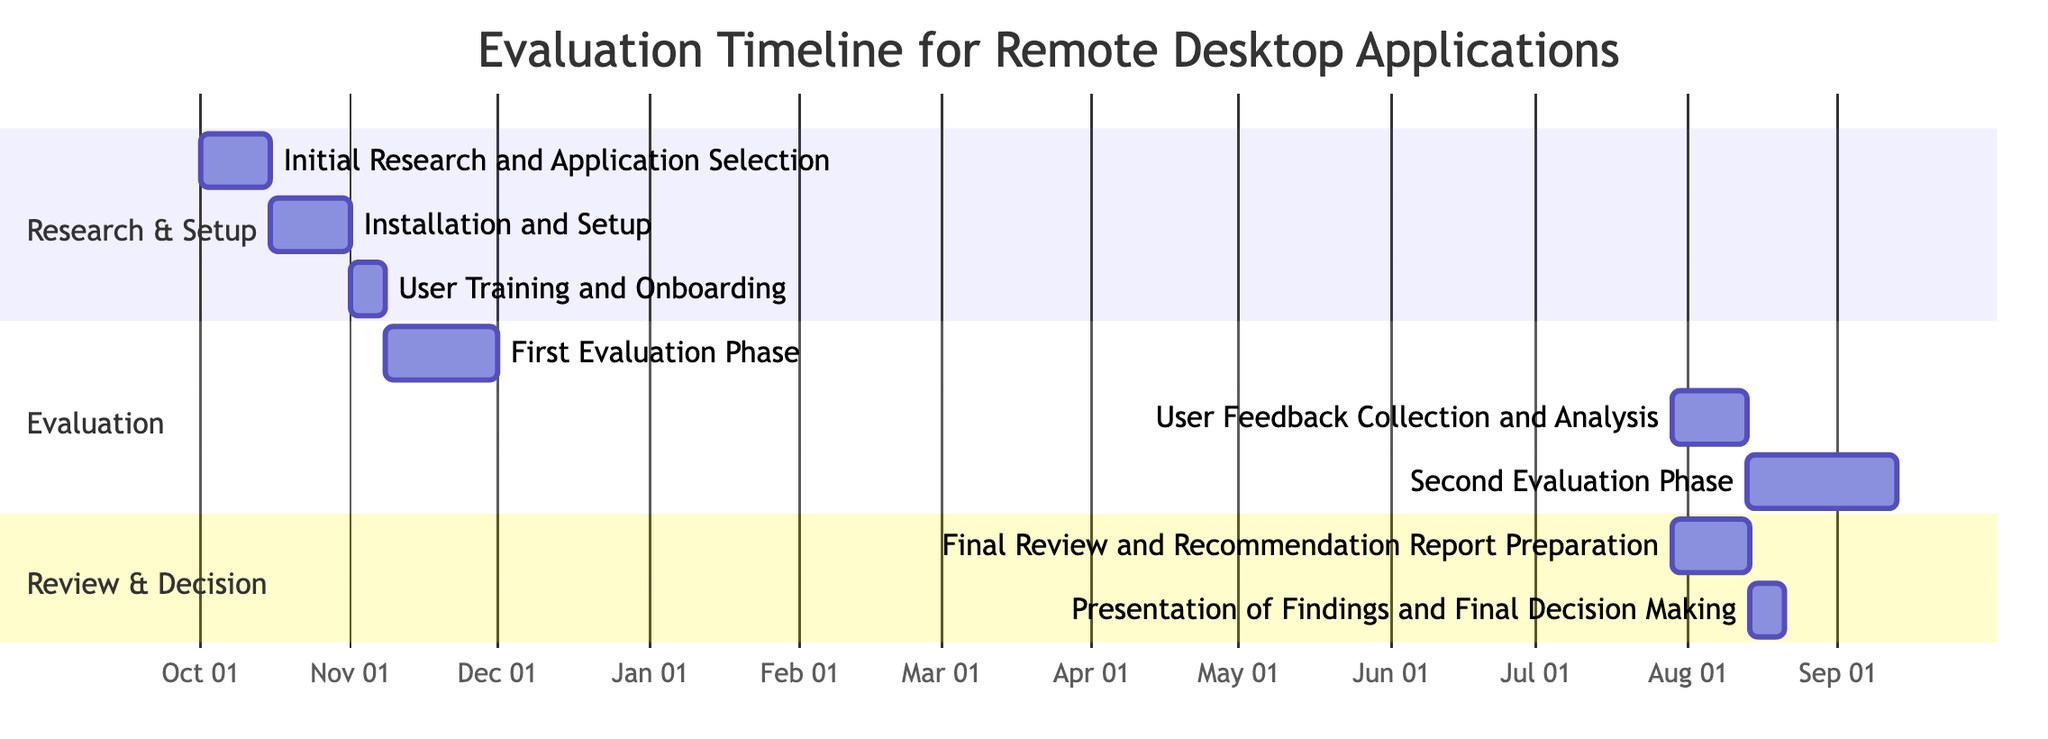What is the duration of the "User Training and Onboarding" task? The "User Training and Onboarding" task starts on November 1, 2023, and ends on November 7, 2023. Counting the duration from start to end gives us a total of 7 days.
Answer: 7 days What task follows "First Evaluation Phase: Performance Metrics Collection"? The task that follows "First Evaluation Phase: Performance Metrics Collection" starts immediately after its completion. It is "User Feedback Collection and Analysis," which starts on December 1, 2023.
Answer: User Feedback Collection and Analysis How many total sections are in the Gantt Chart? The Gantt Chart has three distinct sections: "Research & Setup," "Evaluation," and "Review & Decision." Counting these sections gives us a total of three.
Answer: 3 What is the total duration of the "Final Review and Recommendation Report Preparation"? The "Final Review and Recommendation Report Preparation" task starts on January 16, 2024, and runs until January 31, 2024. This gives us a total of 16 days for its duration.
Answer: 16 days Which task has the earliest start date? The "Initial Research and Application Selection" task has the earliest start date of October 1, 2023, in the Gantt Chart.
Answer: Initial Research and Application Selection What is the relationship between the "User Feedback Collection and Analysis" and "Second Evaluation Phase: Advanced Feature Testing"? "User Feedback Collection and Analysis" is followed by "Second Evaluation Phase: Advanced Feature Testing" in the timeline, indicating that the feedback analysis occurs before advanced feature testing begins.
Answer: Sequential relationship What is the last task in the timeline? The last task in the timeline is "Presentation of Findings and Final Decision Making" which begins on February 1, 2024, and ends on February 7, 2024.
Answer: Presentation of Findings and Final Decision Making Which evaluation phase lasts the longest? The "Second Evaluation Phase: Advanced Feature Testing" lasts 31 days, making it the longest phase in the evaluation section of the Gantt Chart when compared to the other phases.
Answer: Second Evaluation Phase: Advanced Feature Testing 